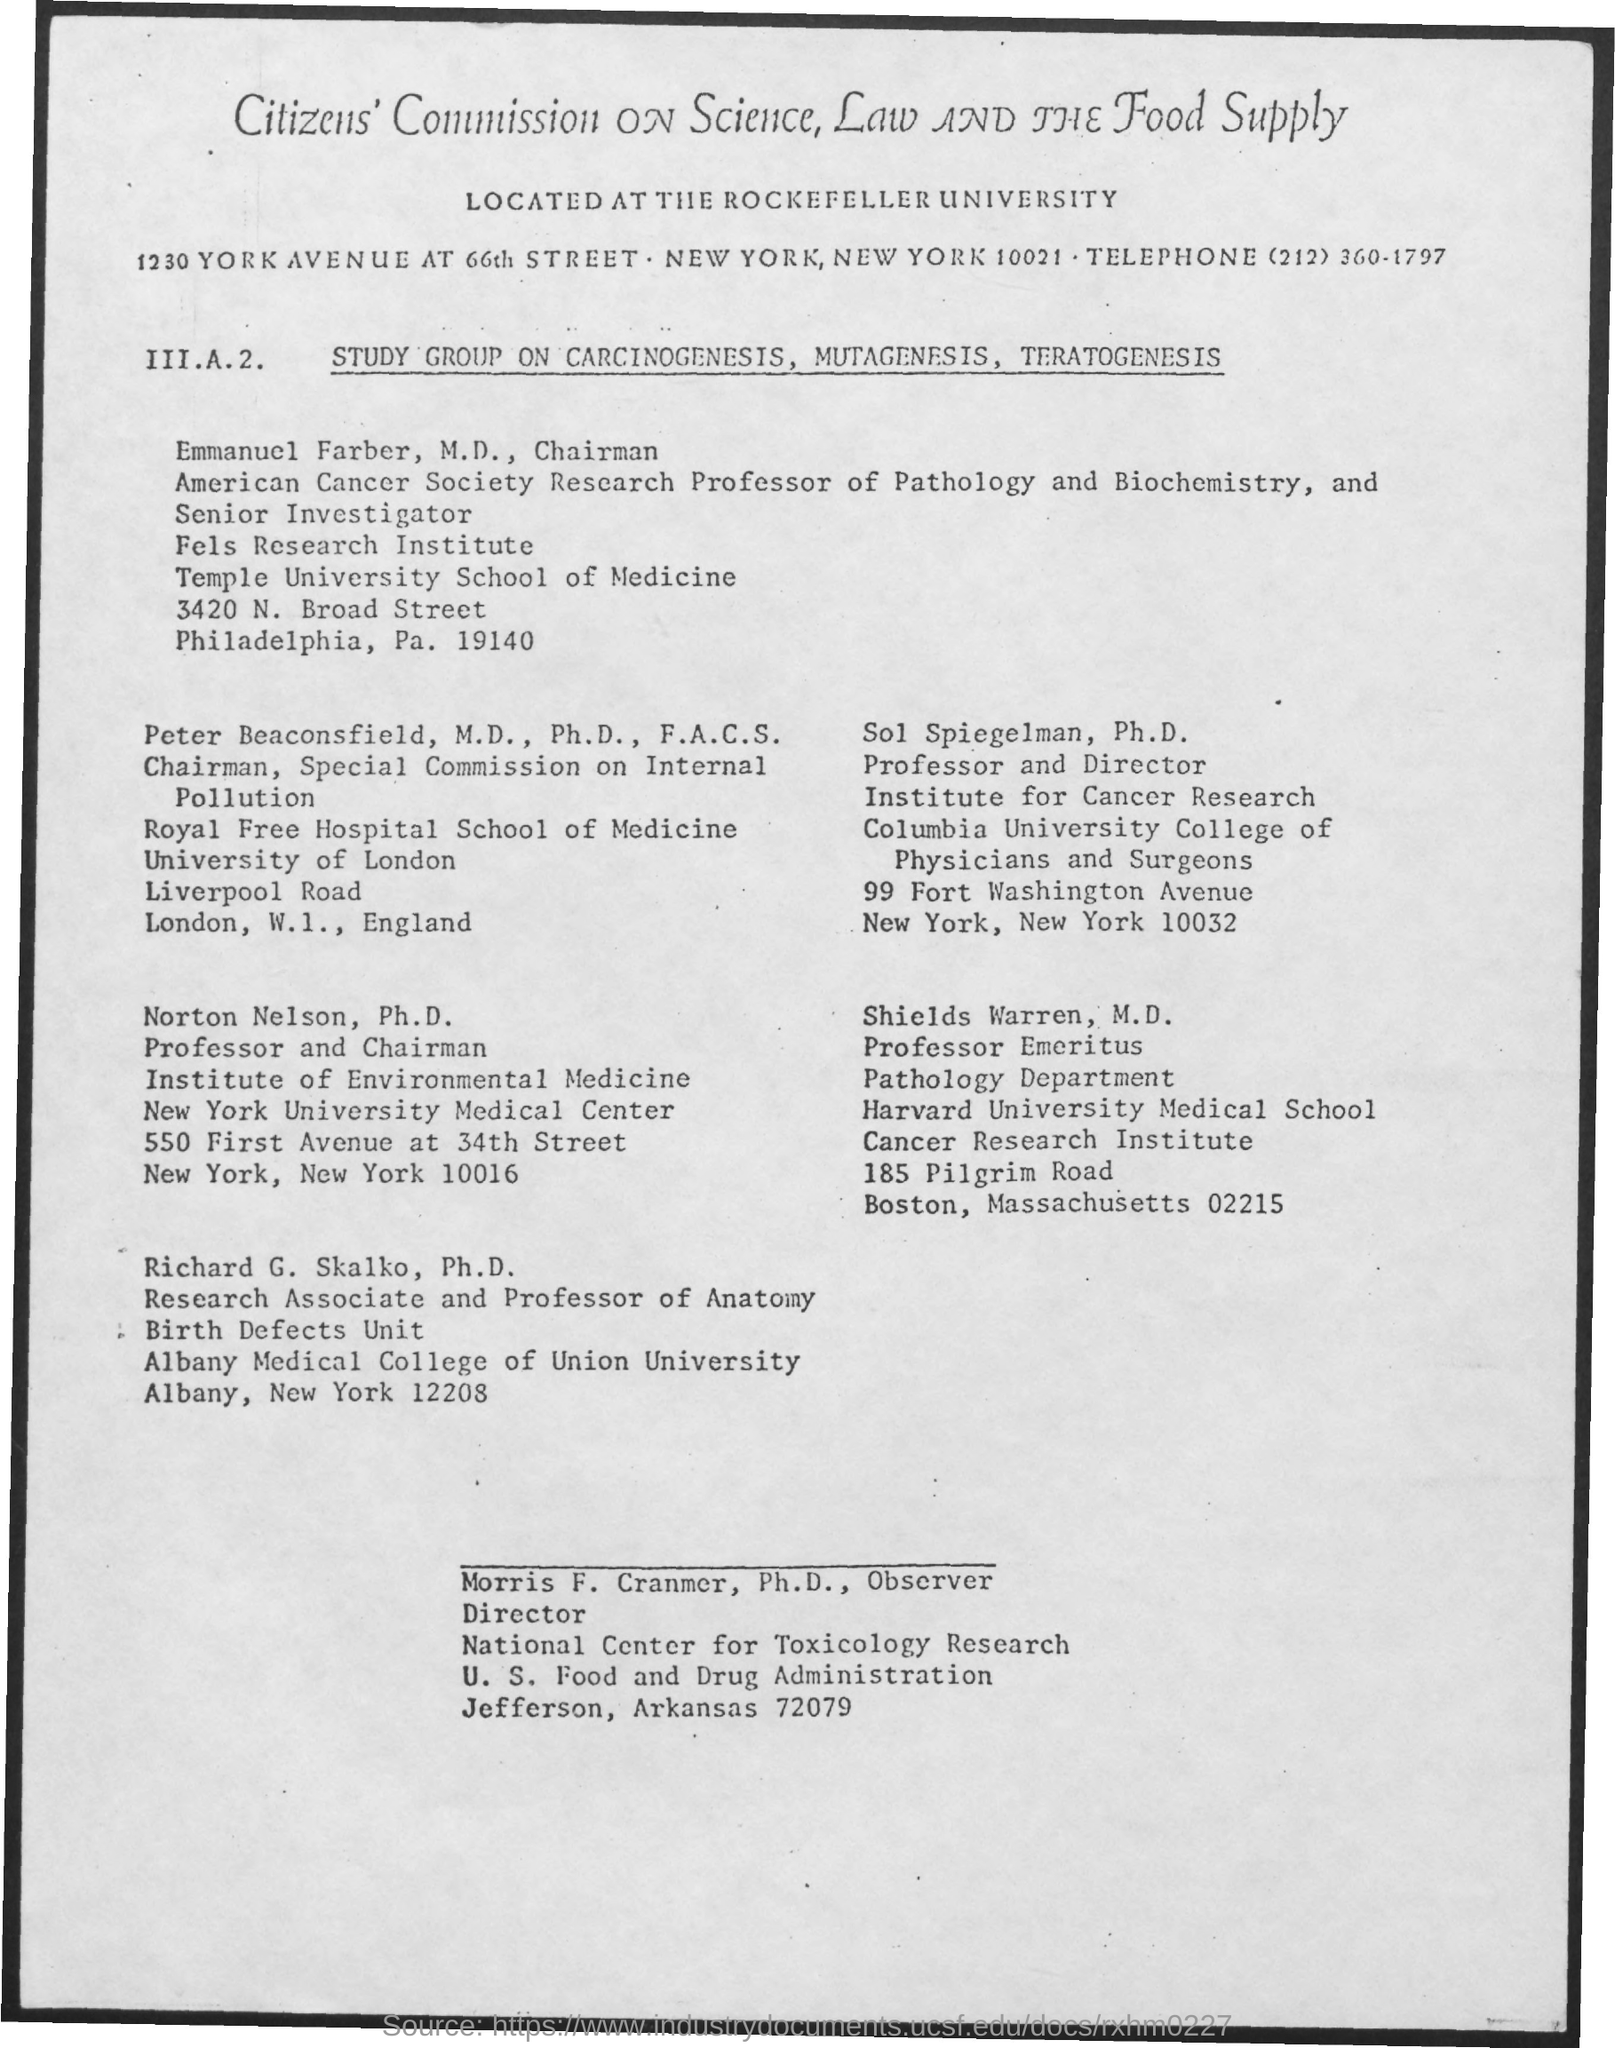Who is the director of National Center for Toxicology Research?
Give a very brief answer. Morris F. Cranmer. Who is the Chairman of Special Commission on Internal Pollution?
Give a very brief answer. Peter Beaconsfield. 